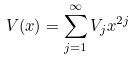<formula> <loc_0><loc_0><loc_500><loc_500>V ( x ) = \sum _ { j = 1 } ^ { \infty } V _ { j } x ^ { 2 j }</formula> 